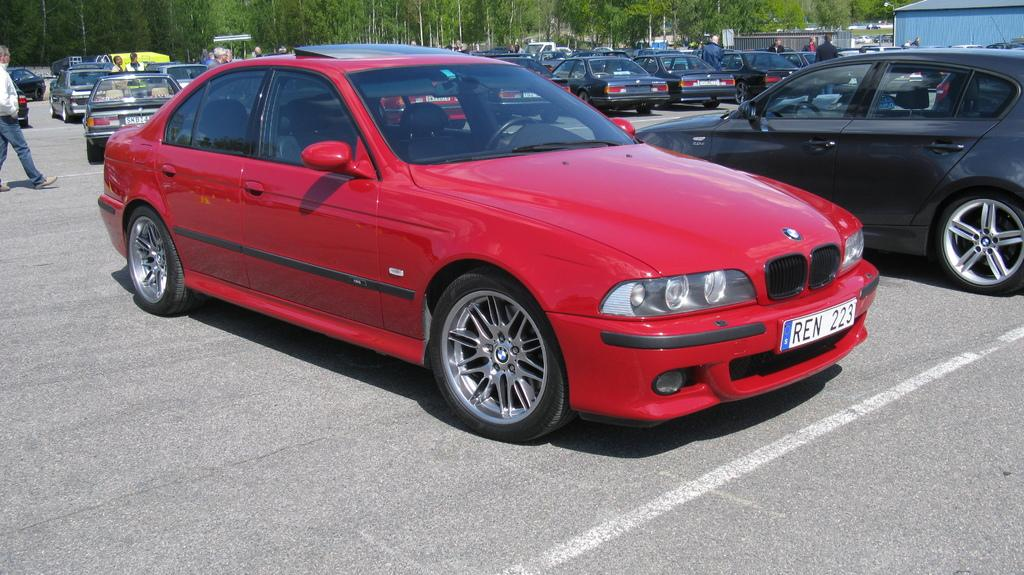What can be seen on the road in the image? There are many cars on the road in the image. Are there any people visible in the image? Yes, there are people in the image. What can be seen in the distance in the image? There are trees and a shed in the background of the image. What type of spoon is being used by the camera in the image? There is no spoon or camera present in the image. 